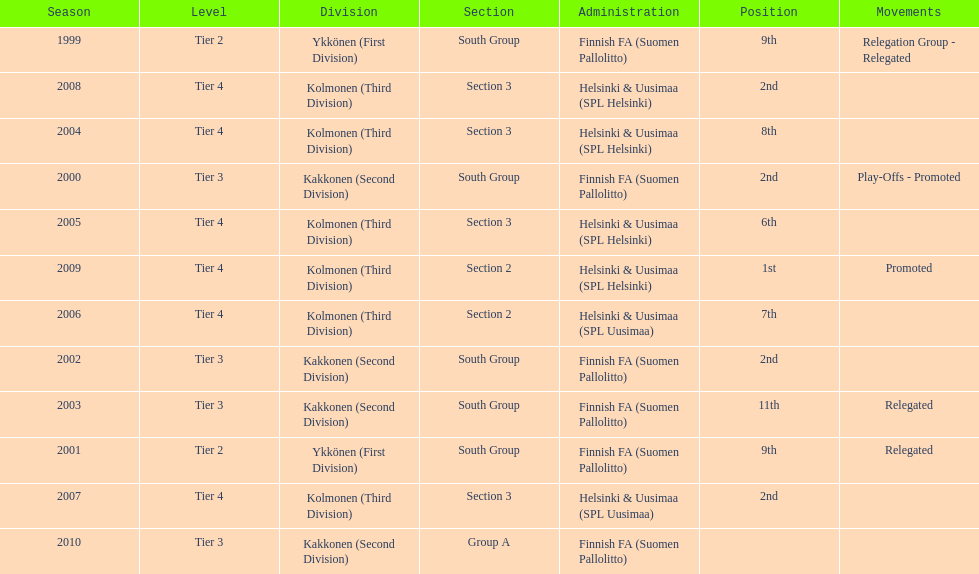How many times has this team been relegated? 3. 